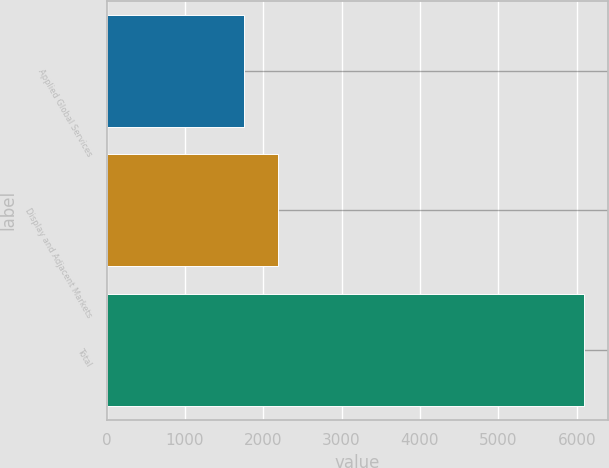<chart> <loc_0><loc_0><loc_500><loc_500><bar_chart><fcel>Applied Global Services<fcel>Display and Adjacent Markets<fcel>Total<nl><fcel>1751<fcel>2185.1<fcel>6092<nl></chart> 